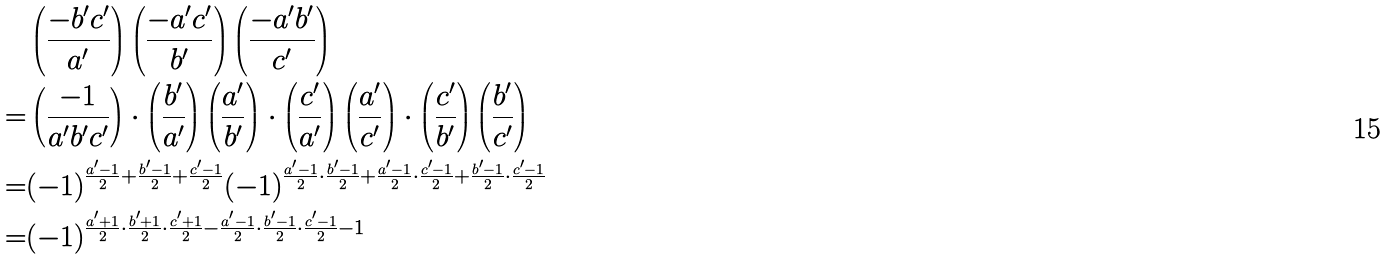<formula> <loc_0><loc_0><loc_500><loc_500>& \left ( \frac { - b ^ { \prime } c ^ { \prime } } { a ^ { \prime } } \right ) \left ( \frac { - a ^ { \prime } c ^ { \prime } } { b ^ { \prime } } \right ) \left ( \frac { - a ^ { \prime } b ^ { \prime } } { c ^ { \prime } } \right ) \\ = & \left ( \frac { - 1 } { a ^ { \prime } b ^ { \prime } c ^ { \prime } } \right ) \cdot \left ( \frac { b ^ { \prime } } { a ^ { \prime } } \right ) \left ( \frac { a ^ { \prime } } { b ^ { \prime } } \right ) \cdot \left ( \frac { c ^ { \prime } } { a ^ { \prime } } \right ) \left ( \frac { a ^ { \prime } } { c ^ { \prime } } \right ) \cdot \left ( \frac { c ^ { \prime } } { b ^ { \prime } } \right ) \left ( \frac { b ^ { \prime } } { c ^ { \prime } } \right ) \\ = & ( - 1 ) ^ { \frac { a ^ { \prime } - 1 } { 2 } + \frac { b ^ { \prime } - 1 } { 2 } + \frac { c ^ { \prime } - 1 } { 2 } } ( - 1 ) ^ { \frac { a ^ { \prime } - 1 } { 2 } \cdot \frac { b ^ { \prime } - 1 } { 2 } + \frac { a ^ { \prime } - 1 } { 2 } \cdot \frac { c ^ { \prime } - 1 } { 2 } + \frac { b ^ { \prime } - 1 } { 2 } \cdot \frac { c ^ { \prime } - 1 } { 2 } } \\ = & ( - 1 ) ^ { \frac { a ^ { \prime } + 1 } { 2 } \cdot \frac { b ^ { \prime } + 1 } { 2 } \cdot \frac { c ^ { \prime } + 1 } { 2 } - \frac { a ^ { \prime } - 1 } { 2 } \cdot \frac { b ^ { \prime } - 1 } { 2 } \cdot \frac { c ^ { \prime } - 1 } { 2 } - 1 }</formula> 